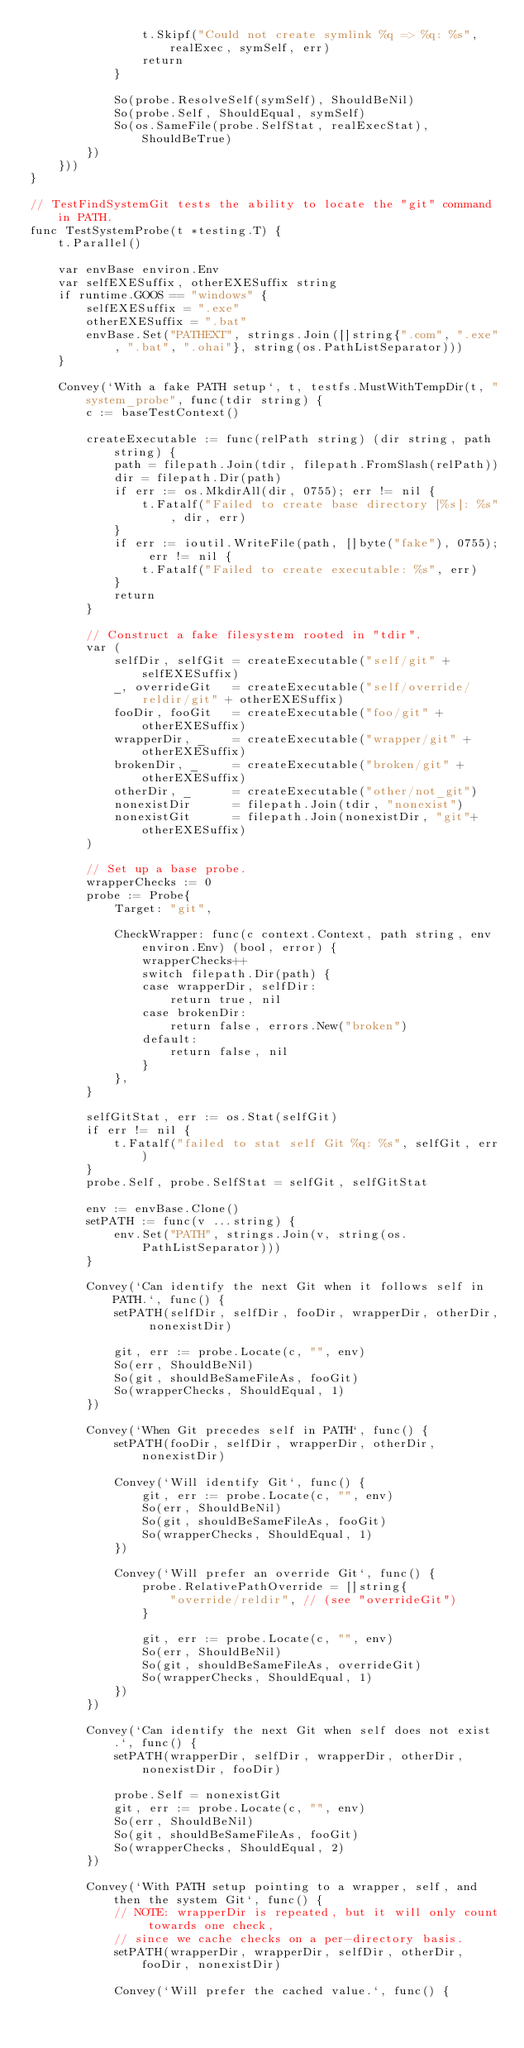Convert code to text. <code><loc_0><loc_0><loc_500><loc_500><_Go_>				t.Skipf("Could not create symlink %q => %q: %s", realExec, symSelf, err)
				return
			}

			So(probe.ResolveSelf(symSelf), ShouldBeNil)
			So(probe.Self, ShouldEqual, symSelf)
			So(os.SameFile(probe.SelfStat, realExecStat), ShouldBeTrue)
		})
	}))
}

// TestFindSystemGit tests the ability to locate the "git" command in PATH.
func TestSystemProbe(t *testing.T) {
	t.Parallel()

	var envBase environ.Env
	var selfEXESuffix, otherEXESuffix string
	if runtime.GOOS == "windows" {
		selfEXESuffix = ".exe"
		otherEXESuffix = ".bat"
		envBase.Set("PATHEXT", strings.Join([]string{".com", ".exe", ".bat", ".ohai"}, string(os.PathListSeparator)))
	}

	Convey(`With a fake PATH setup`, t, testfs.MustWithTempDir(t, "system_probe", func(tdir string) {
		c := baseTestContext()

		createExecutable := func(relPath string) (dir string, path string) {
			path = filepath.Join(tdir, filepath.FromSlash(relPath))
			dir = filepath.Dir(path)
			if err := os.MkdirAll(dir, 0755); err != nil {
				t.Fatalf("Failed to create base directory [%s]: %s", dir, err)
			}
			if err := ioutil.WriteFile(path, []byte("fake"), 0755); err != nil {
				t.Fatalf("Failed to create executable: %s", err)
			}
			return
		}

		// Construct a fake filesystem rooted in "tdir".
		var (
			selfDir, selfGit = createExecutable("self/git" + selfEXESuffix)
			_, overrideGit   = createExecutable("self/override/reldir/git" + otherEXESuffix)
			fooDir, fooGit   = createExecutable("foo/git" + otherEXESuffix)
			wrapperDir, _    = createExecutable("wrapper/git" + otherEXESuffix)
			brokenDir, _     = createExecutable("broken/git" + otherEXESuffix)
			otherDir, _      = createExecutable("other/not_git")
			nonexistDir      = filepath.Join(tdir, "nonexist")
			nonexistGit      = filepath.Join(nonexistDir, "git"+otherEXESuffix)
		)

		// Set up a base probe.
		wrapperChecks := 0
		probe := Probe{
			Target: "git",

			CheckWrapper: func(c context.Context, path string, env environ.Env) (bool, error) {
				wrapperChecks++
				switch filepath.Dir(path) {
				case wrapperDir, selfDir:
					return true, nil
				case brokenDir:
					return false, errors.New("broken")
				default:
					return false, nil
				}
			},
		}

		selfGitStat, err := os.Stat(selfGit)
		if err != nil {
			t.Fatalf("failed to stat self Git %q: %s", selfGit, err)
		}
		probe.Self, probe.SelfStat = selfGit, selfGitStat

		env := envBase.Clone()
		setPATH := func(v ...string) {
			env.Set("PATH", strings.Join(v, string(os.PathListSeparator)))
		}

		Convey(`Can identify the next Git when it follows self in PATH.`, func() {
			setPATH(selfDir, selfDir, fooDir, wrapperDir, otherDir, nonexistDir)

			git, err := probe.Locate(c, "", env)
			So(err, ShouldBeNil)
			So(git, shouldBeSameFileAs, fooGit)
			So(wrapperChecks, ShouldEqual, 1)
		})

		Convey(`When Git precedes self in PATH`, func() {
			setPATH(fooDir, selfDir, wrapperDir, otherDir, nonexistDir)

			Convey(`Will identify Git`, func() {
				git, err := probe.Locate(c, "", env)
				So(err, ShouldBeNil)
				So(git, shouldBeSameFileAs, fooGit)
				So(wrapperChecks, ShouldEqual, 1)
			})

			Convey(`Will prefer an override Git`, func() {
				probe.RelativePathOverride = []string{
					"override/reldir", // (see "overrideGit")
				}

				git, err := probe.Locate(c, "", env)
				So(err, ShouldBeNil)
				So(git, shouldBeSameFileAs, overrideGit)
				So(wrapperChecks, ShouldEqual, 1)
			})
		})

		Convey(`Can identify the next Git when self does not exist.`, func() {
			setPATH(wrapperDir, selfDir, wrapperDir, otherDir, nonexistDir, fooDir)

			probe.Self = nonexistGit
			git, err := probe.Locate(c, "", env)
			So(err, ShouldBeNil)
			So(git, shouldBeSameFileAs, fooGit)
			So(wrapperChecks, ShouldEqual, 2)
		})

		Convey(`With PATH setup pointing to a wrapper, self, and then the system Git`, func() {
			// NOTE: wrapperDir is repeated, but it will only count towards one check,
			// since we cache checks on a per-directory basis.
			setPATH(wrapperDir, wrapperDir, selfDir, otherDir, fooDir, nonexistDir)

			Convey(`Will prefer the cached value.`, func() {</code> 